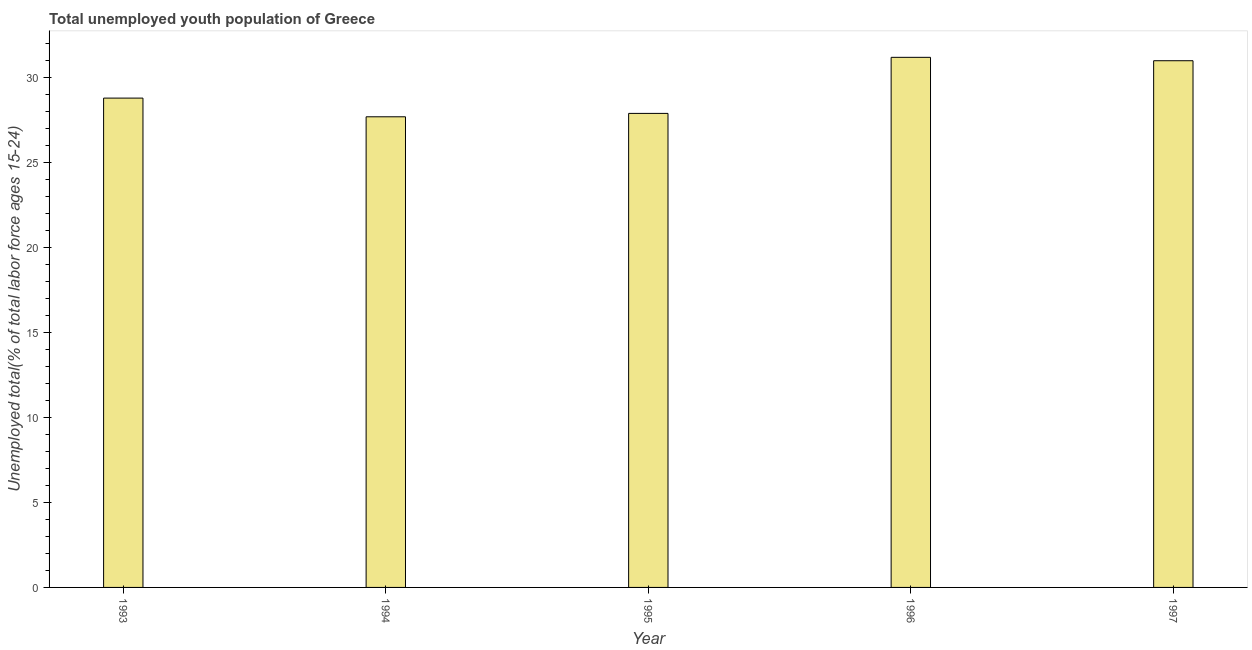Does the graph contain any zero values?
Your answer should be very brief. No. Does the graph contain grids?
Your answer should be compact. No. What is the title of the graph?
Make the answer very short. Total unemployed youth population of Greece. What is the label or title of the X-axis?
Give a very brief answer. Year. What is the label or title of the Y-axis?
Make the answer very short. Unemployed total(% of total labor force ages 15-24). What is the unemployed youth in 1993?
Your answer should be very brief. 28.8. Across all years, what is the maximum unemployed youth?
Make the answer very short. 31.2. Across all years, what is the minimum unemployed youth?
Offer a terse response. 27.7. What is the sum of the unemployed youth?
Keep it short and to the point. 146.6. What is the difference between the unemployed youth in 1994 and 1997?
Offer a terse response. -3.3. What is the average unemployed youth per year?
Give a very brief answer. 29.32. What is the median unemployed youth?
Your answer should be compact. 28.8. In how many years, is the unemployed youth greater than 21 %?
Give a very brief answer. 5. What is the ratio of the unemployed youth in 1994 to that in 1996?
Your response must be concise. 0.89. Is the sum of the unemployed youth in 1993 and 1995 greater than the maximum unemployed youth across all years?
Offer a very short reply. Yes. In how many years, is the unemployed youth greater than the average unemployed youth taken over all years?
Make the answer very short. 2. How many bars are there?
Ensure brevity in your answer.  5. Are all the bars in the graph horizontal?
Your answer should be compact. No. How many years are there in the graph?
Provide a short and direct response. 5. What is the difference between two consecutive major ticks on the Y-axis?
Offer a terse response. 5. What is the Unemployed total(% of total labor force ages 15-24) of 1993?
Provide a short and direct response. 28.8. What is the Unemployed total(% of total labor force ages 15-24) of 1994?
Keep it short and to the point. 27.7. What is the Unemployed total(% of total labor force ages 15-24) in 1995?
Your answer should be compact. 27.9. What is the Unemployed total(% of total labor force ages 15-24) in 1996?
Ensure brevity in your answer.  31.2. What is the Unemployed total(% of total labor force ages 15-24) of 1997?
Your answer should be very brief. 31. What is the difference between the Unemployed total(% of total labor force ages 15-24) in 1993 and 1994?
Provide a succinct answer. 1.1. What is the difference between the Unemployed total(% of total labor force ages 15-24) in 1993 and 1997?
Ensure brevity in your answer.  -2.2. What is the difference between the Unemployed total(% of total labor force ages 15-24) in 1994 and 1997?
Offer a terse response. -3.3. What is the difference between the Unemployed total(% of total labor force ages 15-24) in 1995 and 1997?
Provide a short and direct response. -3.1. What is the difference between the Unemployed total(% of total labor force ages 15-24) in 1996 and 1997?
Provide a short and direct response. 0.2. What is the ratio of the Unemployed total(% of total labor force ages 15-24) in 1993 to that in 1995?
Offer a terse response. 1.03. What is the ratio of the Unemployed total(% of total labor force ages 15-24) in 1993 to that in 1996?
Offer a very short reply. 0.92. What is the ratio of the Unemployed total(% of total labor force ages 15-24) in 1993 to that in 1997?
Provide a short and direct response. 0.93. What is the ratio of the Unemployed total(% of total labor force ages 15-24) in 1994 to that in 1995?
Provide a succinct answer. 0.99. What is the ratio of the Unemployed total(% of total labor force ages 15-24) in 1994 to that in 1996?
Provide a short and direct response. 0.89. What is the ratio of the Unemployed total(% of total labor force ages 15-24) in 1994 to that in 1997?
Offer a very short reply. 0.89. What is the ratio of the Unemployed total(% of total labor force ages 15-24) in 1995 to that in 1996?
Offer a very short reply. 0.89. 